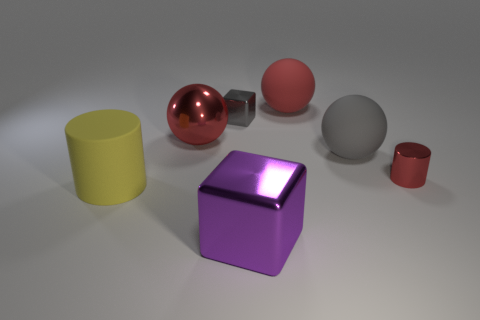Is there a shiny block that is to the right of the gray metal block that is left of the cylinder on the right side of the yellow thing?
Your answer should be compact. Yes. What material is the tiny object that is on the left side of the metal cylinder?
Keep it short and to the point. Metal. What number of tiny objects are either metal cubes or red spheres?
Make the answer very short. 1. Do the red thing on the left side of the purple metallic object and the gray matte object have the same size?
Your answer should be compact. Yes. How many other objects are the same color as the large cylinder?
Provide a succinct answer. 0. What is the large cylinder made of?
Your answer should be very brief. Rubber. What is the large thing that is in front of the small red cylinder and left of the large purple shiny thing made of?
Offer a terse response. Rubber. What number of objects are either small objects behind the tiny cylinder or big yellow shiny things?
Provide a succinct answer. 1. Does the metallic sphere have the same color as the small cylinder?
Your answer should be very brief. Yes. Are there any gray metal things that have the same size as the red metal cylinder?
Ensure brevity in your answer.  Yes. 